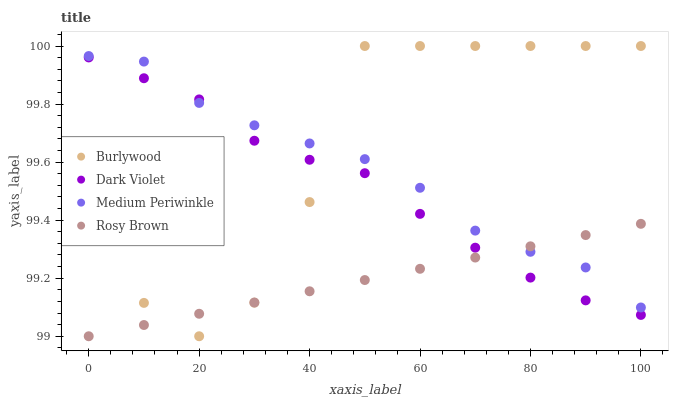Does Rosy Brown have the minimum area under the curve?
Answer yes or no. Yes. Does Burlywood have the maximum area under the curve?
Answer yes or no. Yes. Does Medium Periwinkle have the minimum area under the curve?
Answer yes or no. No. Does Medium Periwinkle have the maximum area under the curve?
Answer yes or no. No. Is Rosy Brown the smoothest?
Answer yes or no. Yes. Is Burlywood the roughest?
Answer yes or no. Yes. Is Medium Periwinkle the smoothest?
Answer yes or no. No. Is Medium Periwinkle the roughest?
Answer yes or no. No. Does Rosy Brown have the lowest value?
Answer yes or no. Yes. Does Medium Periwinkle have the lowest value?
Answer yes or no. No. Does Burlywood have the highest value?
Answer yes or no. Yes. Does Medium Periwinkle have the highest value?
Answer yes or no. No. Does Rosy Brown intersect Medium Periwinkle?
Answer yes or no. Yes. Is Rosy Brown less than Medium Periwinkle?
Answer yes or no. No. Is Rosy Brown greater than Medium Periwinkle?
Answer yes or no. No. 